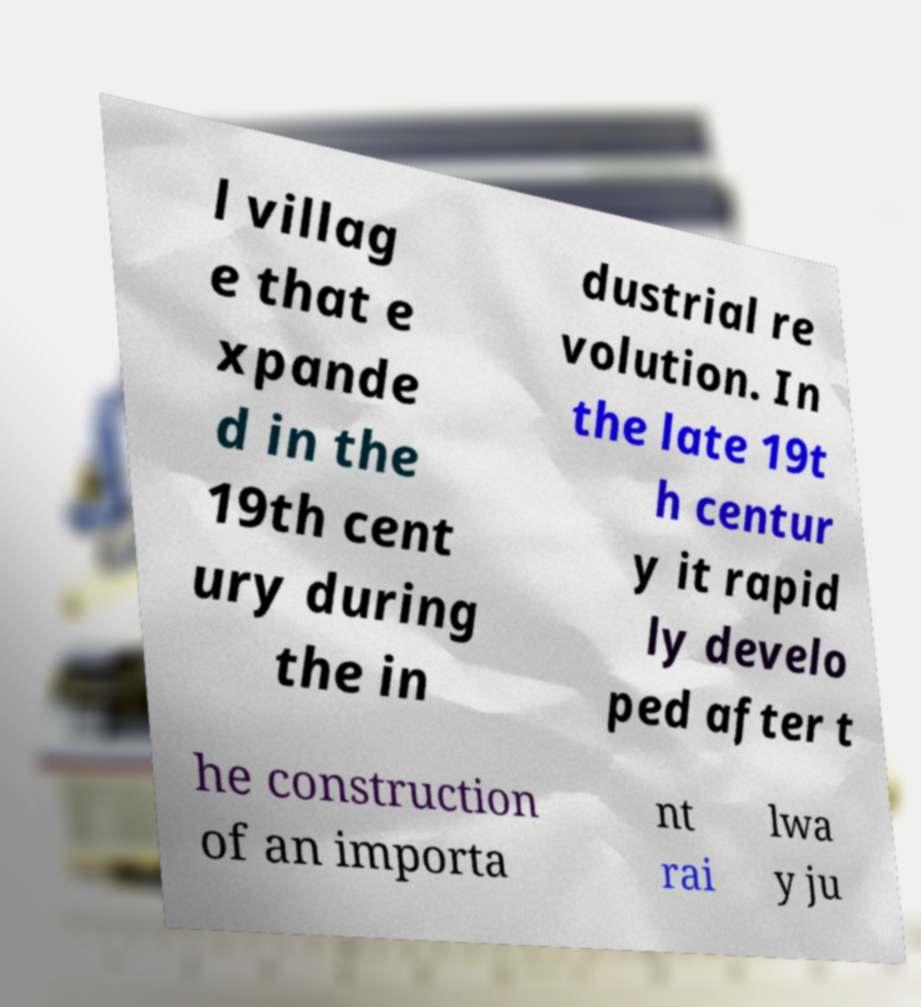What messages or text are displayed in this image? I need them in a readable, typed format. l villag e that e xpande d in the 19th cent ury during the in dustrial re volution. In the late 19t h centur y it rapid ly develo ped after t he construction of an importa nt rai lwa y ju 